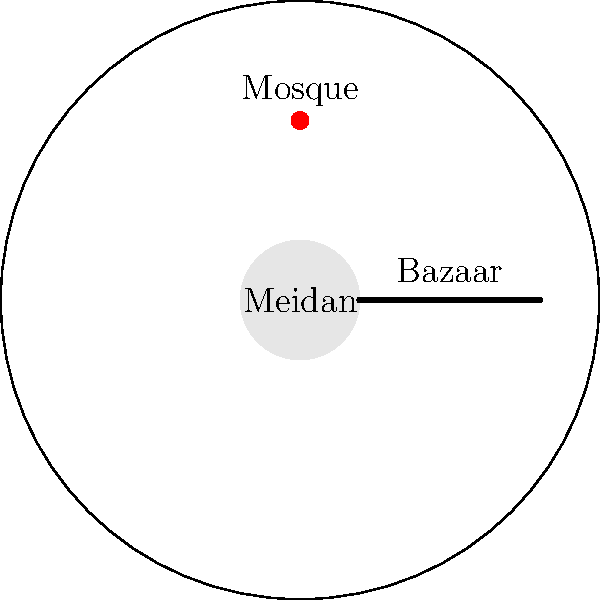In the diagram of a typical Iranian city layout, which element is typically located at the center and serves as the main public space? To answer this question, let's analyze the key components of a typical Iranian city layout:

1. The diagram shows a circular city outline, representing the traditional compact form of Iranian cities.

2. At the very center of the city, we see a circular area labeled "Meidan". This is a crucial element in Iranian urban design.

3. The Meidan, also known as the main square, is typically the heart of the city and serves multiple functions:
   a) It acts as a central public space for gatherings and social interactions.
   b) It often connects to other important urban elements.

4. We can observe that other key elements are arranged around or connected to the Meidan:
   a) The Bazaar extends from the Meidan towards one of the city gates.
   b) The main Mosque is located near the Meidan.
   c) Residential areas and gardens are arranged in different sectors around the central area.

5. This central location of the Meidan allows it to serve as a hub connecting various city functions and facilitating urban life.

Given these observations, we can conclude that the Meidan, or central square, is the element typically located at the center of an Iranian city and serves as the main public space.
Answer: Meidan (central square) 